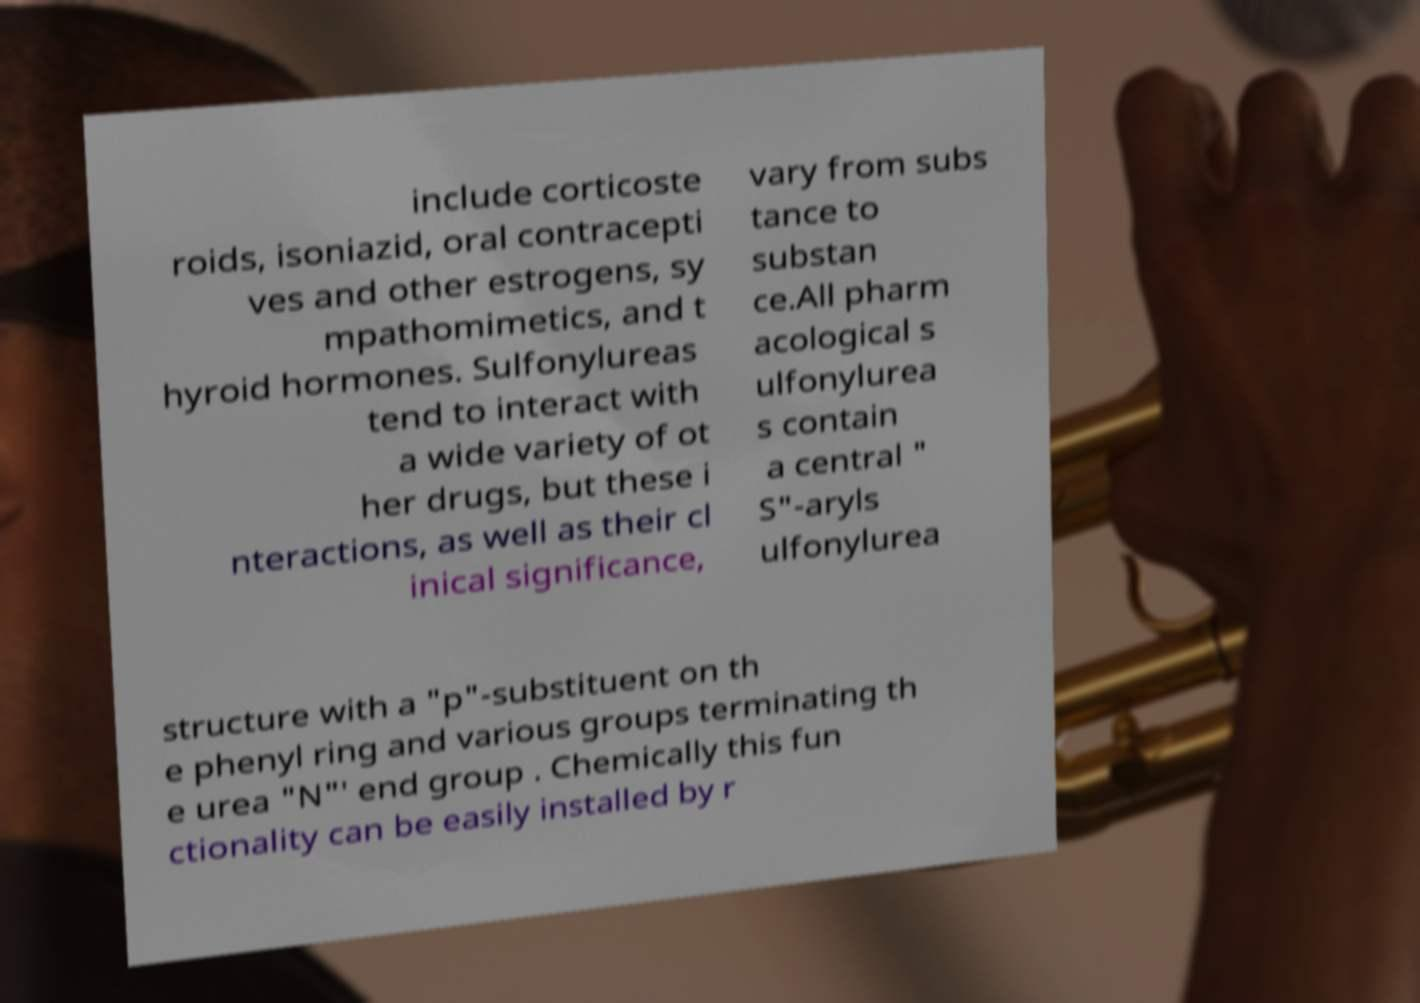Can you accurately transcribe the text from the provided image for me? include corticoste roids, isoniazid, oral contracepti ves and other estrogens, sy mpathomimetics, and t hyroid hormones. Sulfonylureas tend to interact with a wide variety of ot her drugs, but these i nteractions, as well as their cl inical significance, vary from subs tance to substan ce.All pharm acological s ulfonylurea s contain a central " S"-aryls ulfonylurea structure with a "p"-substituent on th e phenyl ring and various groups terminating th e urea "N"′ end group . Chemically this fun ctionality can be easily installed by r 